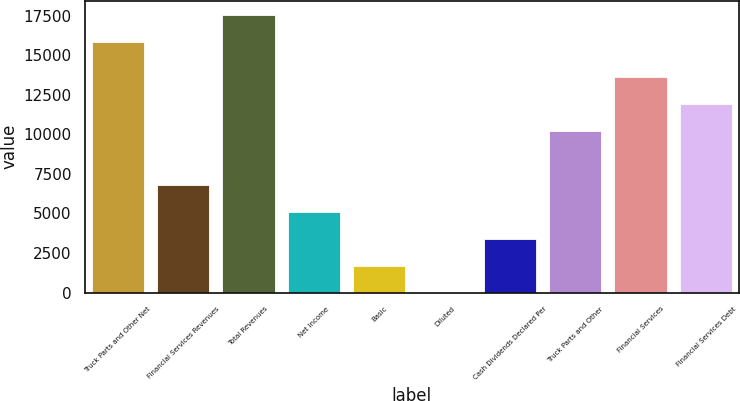Convert chart. <chart><loc_0><loc_0><loc_500><loc_500><bar_chart><fcel>Truck Parts and Other Net<fcel>Financial Services Revenues<fcel>Total Revenues<fcel>Net Income<fcel>Basic<fcel>Diluted<fcel>Cash Dividends Declared Per<fcel>Truck Parts and Other<fcel>Financial Services<fcel>Financial Services Debt<nl><fcel>15846.6<fcel>6814.2<fcel>17549.8<fcel>5111.02<fcel>1704.66<fcel>1.48<fcel>3407.84<fcel>10220.6<fcel>13626.9<fcel>11923.7<nl></chart> 